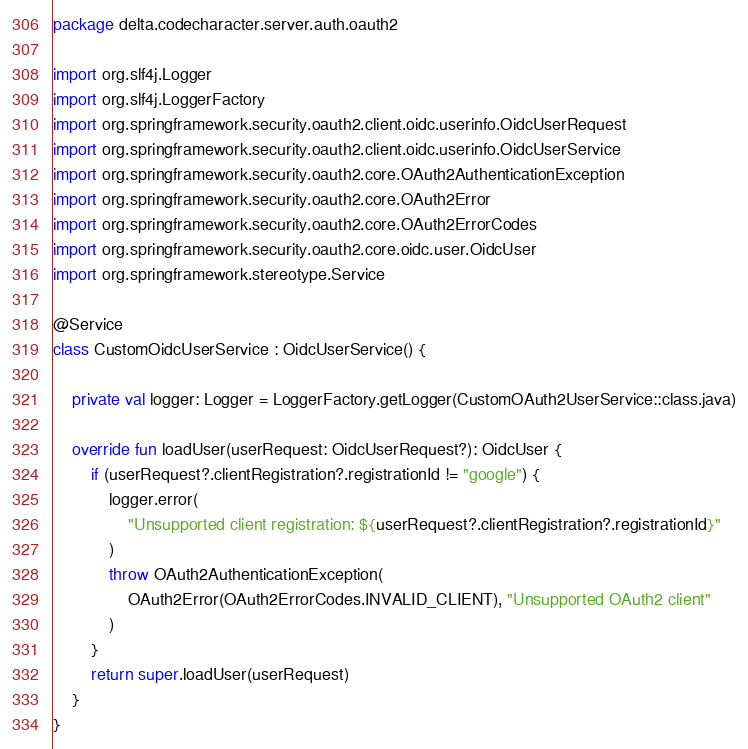Convert code to text. <code><loc_0><loc_0><loc_500><loc_500><_Kotlin_>package delta.codecharacter.server.auth.oauth2

import org.slf4j.Logger
import org.slf4j.LoggerFactory
import org.springframework.security.oauth2.client.oidc.userinfo.OidcUserRequest
import org.springframework.security.oauth2.client.oidc.userinfo.OidcUserService
import org.springframework.security.oauth2.core.OAuth2AuthenticationException
import org.springframework.security.oauth2.core.OAuth2Error
import org.springframework.security.oauth2.core.OAuth2ErrorCodes
import org.springframework.security.oauth2.core.oidc.user.OidcUser
import org.springframework.stereotype.Service

@Service
class CustomOidcUserService : OidcUserService() {

    private val logger: Logger = LoggerFactory.getLogger(CustomOAuth2UserService::class.java)

    override fun loadUser(userRequest: OidcUserRequest?): OidcUser {
        if (userRequest?.clientRegistration?.registrationId != "google") {
            logger.error(
                "Unsupported client registration: ${userRequest?.clientRegistration?.registrationId}"
            )
            throw OAuth2AuthenticationException(
                OAuth2Error(OAuth2ErrorCodes.INVALID_CLIENT), "Unsupported OAuth2 client"
            )
        }
        return super.loadUser(userRequest)
    }
}
</code> 